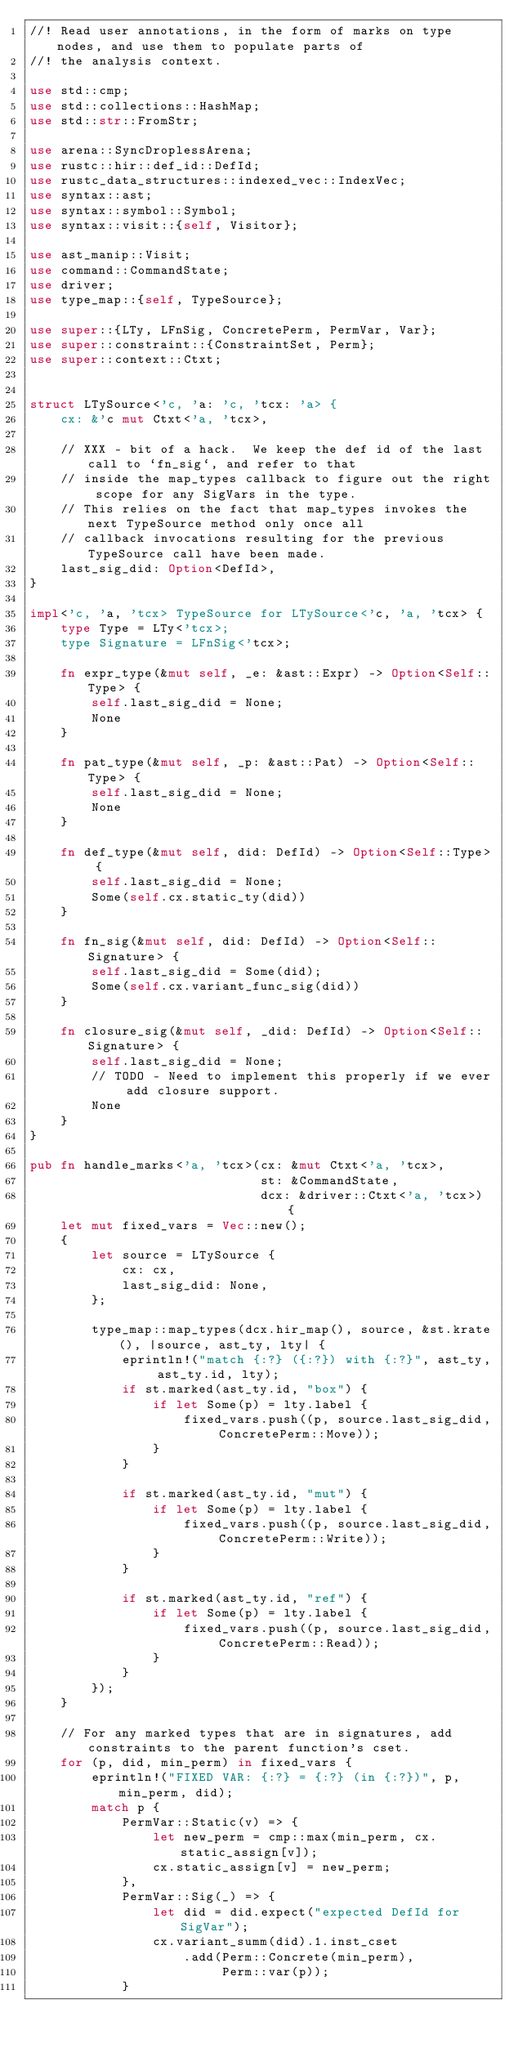<code> <loc_0><loc_0><loc_500><loc_500><_Rust_>//! Read user annotations, in the form of marks on type nodes, and use them to populate parts of
//! the analysis context.

use std::cmp;
use std::collections::HashMap;
use std::str::FromStr;

use arena::SyncDroplessArena;
use rustc::hir::def_id::DefId;
use rustc_data_structures::indexed_vec::IndexVec;
use syntax::ast;
use syntax::symbol::Symbol;
use syntax::visit::{self, Visitor};

use ast_manip::Visit;
use command::CommandState;
use driver;
use type_map::{self, TypeSource};

use super::{LTy, LFnSig, ConcretePerm, PermVar, Var};
use super::constraint::{ConstraintSet, Perm};
use super::context::Ctxt;


struct LTySource<'c, 'a: 'c, 'tcx: 'a> {
    cx: &'c mut Ctxt<'a, 'tcx>,

    // XXX - bit of a hack.  We keep the def id of the last call to `fn_sig`, and refer to that
    // inside the map_types callback to figure out the right scope for any SigVars in the type.
    // This relies on the fact that map_types invokes the next TypeSource method only once all
    // callback invocations resulting for the previous TypeSource call have been made.
    last_sig_did: Option<DefId>,
}

impl<'c, 'a, 'tcx> TypeSource for LTySource<'c, 'a, 'tcx> {
    type Type = LTy<'tcx>;
    type Signature = LFnSig<'tcx>;

    fn expr_type(&mut self, _e: &ast::Expr) -> Option<Self::Type> {
        self.last_sig_did = None;
        None
    }

    fn pat_type(&mut self, _p: &ast::Pat) -> Option<Self::Type> {
        self.last_sig_did = None;
        None
    }

    fn def_type(&mut self, did: DefId) -> Option<Self::Type> {
        self.last_sig_did = None;
        Some(self.cx.static_ty(did))
    }

    fn fn_sig(&mut self, did: DefId) -> Option<Self::Signature> {
        self.last_sig_did = Some(did);
        Some(self.cx.variant_func_sig(did))
    }

    fn closure_sig(&mut self, _did: DefId) -> Option<Self::Signature> {
        self.last_sig_did = None;
        // TODO - Need to implement this properly if we ever add closure support.
        None
    }
}

pub fn handle_marks<'a, 'tcx>(cx: &mut Ctxt<'a, 'tcx>,
                              st: &CommandState,
                              dcx: &driver::Ctxt<'a, 'tcx>) {
    let mut fixed_vars = Vec::new();
    {
        let source = LTySource {
            cx: cx,
            last_sig_did: None,
        };

        type_map::map_types(dcx.hir_map(), source, &st.krate(), |source, ast_ty, lty| {
            eprintln!("match {:?} ({:?}) with {:?}", ast_ty, ast_ty.id, lty);
            if st.marked(ast_ty.id, "box") {
                if let Some(p) = lty.label {
                    fixed_vars.push((p, source.last_sig_did, ConcretePerm::Move));
                }
            }

            if st.marked(ast_ty.id, "mut") {
                if let Some(p) = lty.label {
                    fixed_vars.push((p, source.last_sig_did, ConcretePerm::Write));
                }
            }

            if st.marked(ast_ty.id, "ref") {
                if let Some(p) = lty.label {
                    fixed_vars.push((p, source.last_sig_did, ConcretePerm::Read));
                }
            }
        });
    }

    // For any marked types that are in signatures, add constraints to the parent function's cset.
    for (p, did, min_perm) in fixed_vars {
        eprintln!("FIXED VAR: {:?} = {:?} (in {:?})", p, min_perm, did);
        match p {
            PermVar::Static(v) => {
                let new_perm = cmp::max(min_perm, cx.static_assign[v]);
                cx.static_assign[v] = new_perm;
            },
            PermVar::Sig(_) => {
                let did = did.expect("expected DefId for SigVar");
                cx.variant_summ(did).1.inst_cset
                    .add(Perm::Concrete(min_perm),
                         Perm::var(p));
            }</code> 